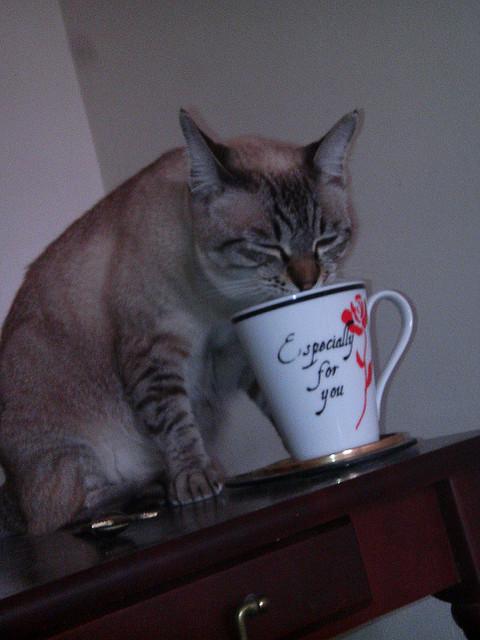Which of the cat's paws is touching the shoe?
Short answer required. 0. Where is the kitten?
Keep it brief. Table. The painting tabby has a darker color variation circling one of his front "arms" - which one?
Give a very brief answer. Right. What thought is likely going through this cat's mind?
Quick response, please. Thirst. Is the cat going to jump?
Quick response, please. No. Where is the cat sitting?
Be succinct. Table. Is this the cat's usual water dish?
Keep it brief. No. Is the cat awake?
Write a very short answer. Yes. Is this a kitten?
Quick response, please. No. What color is the cat?
Quick response, please. Gray. Is the cat sad?
Give a very brief answer. No. Is this cat facing the camera?
Quick response, please. Yes. What is the cat on top of?
Concise answer only. Table. Is it sunny?
Be succinct. No. What color is the wall?
Answer briefly. White. 